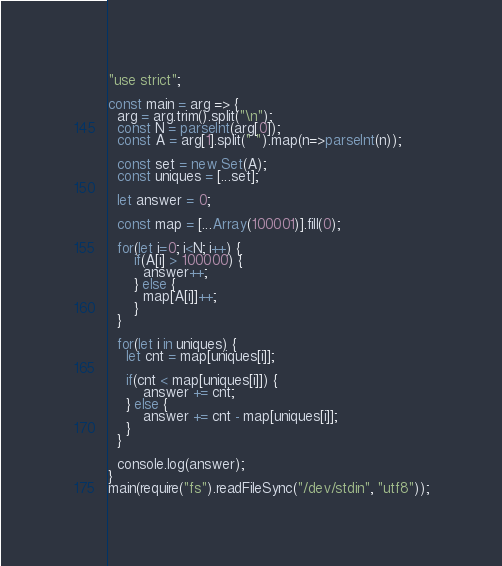<code> <loc_0><loc_0><loc_500><loc_500><_JavaScript_>"use strict";

const main = arg => {
  arg = arg.trim().split("\n");
  const N = parseInt(arg[0]);
  const A = arg[1].split(" ").map(n=>parseInt(n));
  
  const set = new Set(A);
  const uniques = [...set];
  
  let answer = 0;
  
  const map = [...Array(100001)].fill(0);
  
  for(let i=0; i<N; i++) {
      if(A[i] > 100000) {
        answer++;
      } else {
        map[A[i]]++;
      }
  }
  
  for(let i in uniques) {
    let cnt = map[uniques[i]];
    
    if(cnt < map[uniques[i]]) {
        answer += cnt;
    } else {
        answer += cnt - map[uniques[i]];
    }
  }
  
  console.log(answer);
}
main(require("fs").readFileSync("/dev/stdin", "utf8"));
</code> 